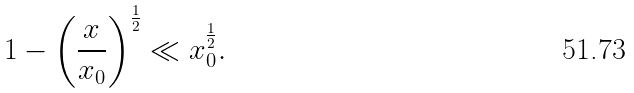<formula> <loc_0><loc_0><loc_500><loc_500>1 - \left ( \frac { x } { x _ { 0 } } \right ) ^ { \frac { 1 } { 2 } } \ll x _ { 0 } ^ { \frac { 1 } { 2 } } .</formula> 